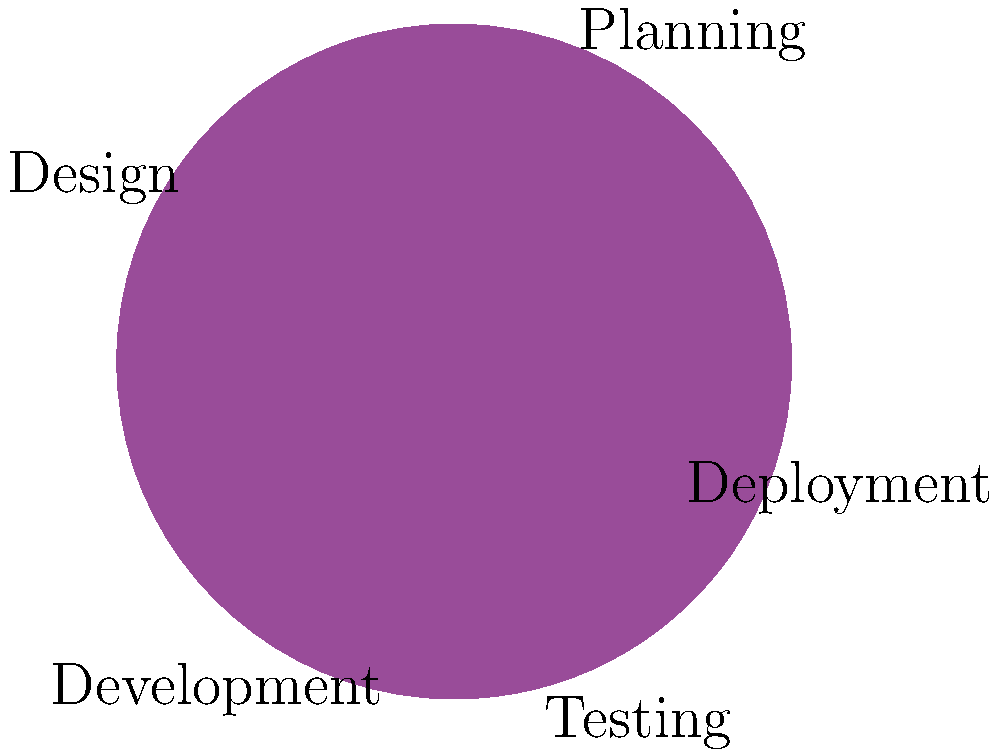As a project manager, you're allocating resources across different phases of a project. The pie chart shows the current distribution. If the total budget is $500,000, how much more is allocated to Planning compared to Deployment? To solve this problem, we need to follow these steps:

1. Identify the percentages for Planning and Deployment from the pie chart:
   Planning: 30%
   Deployment: 10%

2. Calculate the difference in percentage:
   30% - 10% = 20%

3. Calculate the total amount for this percentage difference:
   20% of $500,000 = 0.20 * $500,000 = $100,000

Therefore, the difference in allocation between Planning and Deployment is $100,000.

This calculation shows how a project manager would analyze resource allocation across different phases, ensuring that critical early stages like Planning receive appropriate funding while also maintaining sufficient resources for later stages like Deployment.
Answer: $100,000 